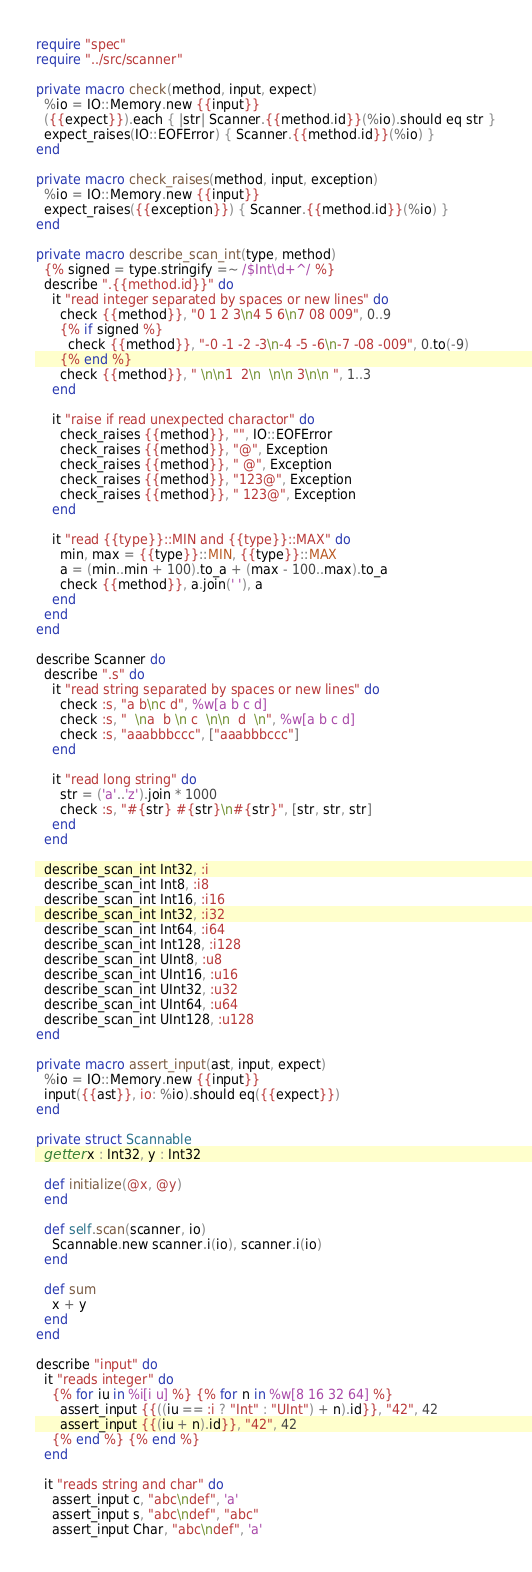Convert code to text. <code><loc_0><loc_0><loc_500><loc_500><_Crystal_>require "spec"
require "../src/scanner"

private macro check(method, input, expect)
  %io = IO::Memory.new {{input}}
  ({{expect}}).each { |str| Scanner.{{method.id}}(%io).should eq str }
  expect_raises(IO::EOFError) { Scanner.{{method.id}}(%io) }
end

private macro check_raises(method, input, exception)
  %io = IO::Memory.new {{input}}
  expect_raises({{exception}}) { Scanner.{{method.id}}(%io) }
end

private macro describe_scan_int(type, method)
  {% signed = type.stringify =~ /$Int\d+^/ %}
  describe ".{{method.id}}" do
    it "read integer separated by spaces or new lines" do
      check {{method}}, "0 1 2 3\n4 5 6\n7 08 009", 0..9
      {% if signed %}
        check {{method}}, "-0 -1 -2 -3\n-4 -5 -6\n-7 -08 -009", 0.to(-9)
      {% end %}
      check {{method}}, " \n\n1  2\n  \n\n 3\n\n ", 1..3
    end

    it "raise if read unexpected charactor" do
      check_raises {{method}}, "", IO::EOFError
      check_raises {{method}}, "@", Exception
      check_raises {{method}}, " @", Exception
      check_raises {{method}}, "123@", Exception
      check_raises {{method}}, " 123@", Exception
    end

    it "read {{type}}::MIN and {{type}}::MAX" do
      min, max = {{type}}::MIN, {{type}}::MAX
      a = (min..min + 100).to_a + (max - 100..max).to_a
      check {{method}}, a.join(' '), a
    end
  end
end

describe Scanner do
  describe ".s" do
    it "read string separated by spaces or new lines" do
      check :s, "a b\nc d", %w[a b c d]
      check :s, "  \na  b \n c  \n\n  d  \n", %w[a b c d]
      check :s, "aaabbbccc", ["aaabbbccc"]
    end

    it "read long string" do
      str = ('a'..'z').join * 1000
      check :s, "#{str} #{str}\n#{str}", [str, str, str]
    end
  end

  describe_scan_int Int32, :i
  describe_scan_int Int8, :i8
  describe_scan_int Int16, :i16
  describe_scan_int Int32, :i32
  describe_scan_int Int64, :i64
  describe_scan_int Int128, :i128
  describe_scan_int UInt8, :u8
  describe_scan_int UInt16, :u16
  describe_scan_int UInt32, :u32
  describe_scan_int UInt64, :u64
  describe_scan_int UInt128, :u128
end

private macro assert_input(ast, input, expect)
  %io = IO::Memory.new {{input}}
  input({{ast}}, io: %io).should eq({{expect}})
end

private struct Scannable
  getter x : Int32, y : Int32

  def initialize(@x, @y)
  end

  def self.scan(scanner, io)
    Scannable.new scanner.i(io), scanner.i(io)
  end

  def sum
    x + y
  end
end

describe "input" do
  it "reads integer" do
    {% for iu in %i[i u] %} {% for n in %w[8 16 32 64] %}
      assert_input {{((iu == :i ? "Int" : "UInt") + n).id}}, "42", 42
      assert_input {{(iu + n).id}}, "42", 42
    {% end %} {% end %}
  end

  it "reads string and char" do
    assert_input c, "abc\ndef", 'a'
    assert_input s, "abc\ndef", "abc"
    assert_input Char, "abc\ndef", 'a'</code> 